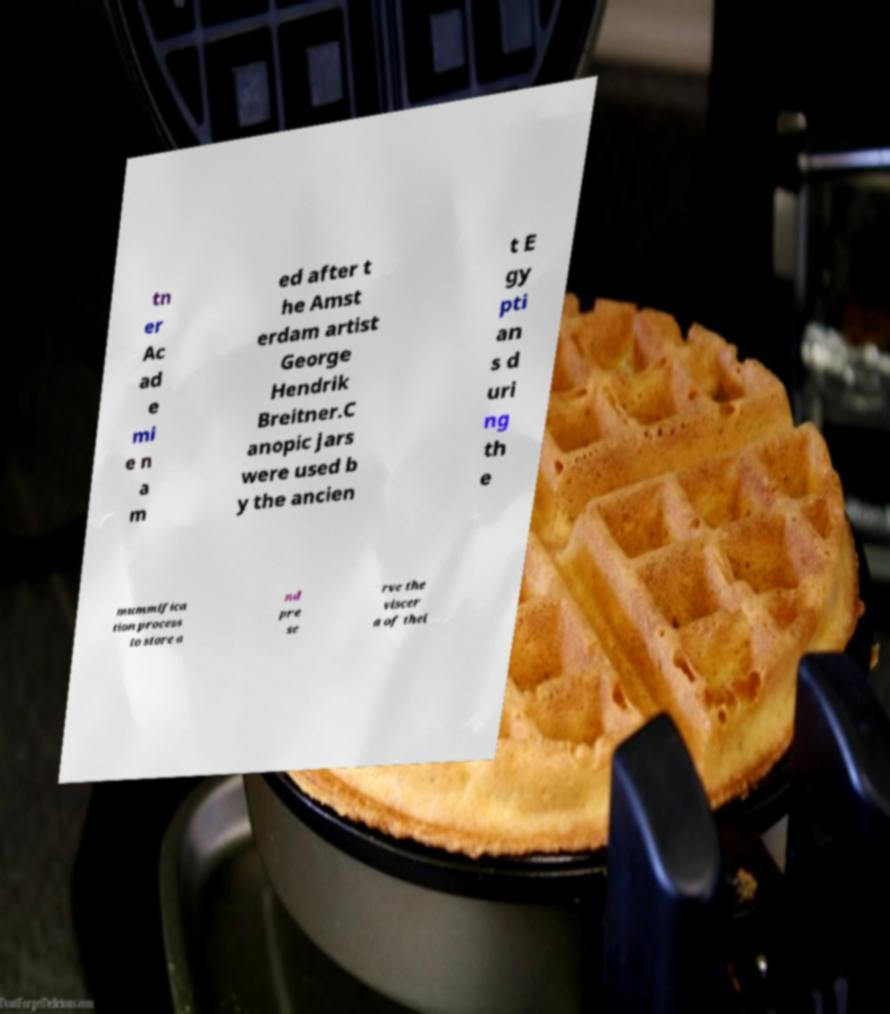Can you read and provide the text displayed in the image?This photo seems to have some interesting text. Can you extract and type it out for me? tn er Ac ad e mi e n a m ed after t he Amst erdam artist George Hendrik Breitner.C anopic jars were used b y the ancien t E gy pti an s d uri ng th e mummifica tion process to store a nd pre se rve the viscer a of thei 